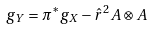Convert formula to latex. <formula><loc_0><loc_0><loc_500><loc_500>g _ { Y } = \pi ^ { * } g _ { X } - \hat { r } ^ { 2 } A \otimes A</formula> 